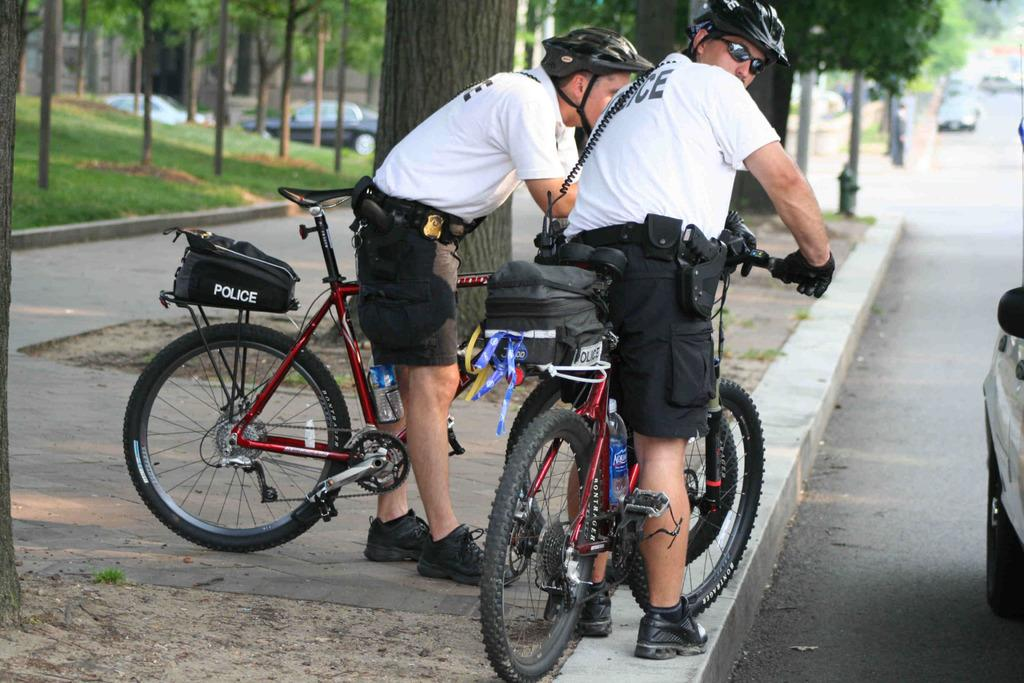How many people are in the image? There are two people in the image. What are the people wearing? Both people are wearing white shirts and black shorts. What protective gear are the people wearing? Both people are wearing helmets. What are the people doing in the image? The people are on bicycles. What type of vegetation can be seen in the image? There are trees and plants in the image. What else is present in the image besides the people and vegetation? There are cars in the image. What type of stew is being prepared in the image? There is no stew present in the image; it features two people on bicycles with trees, plants, and cars in the background. 